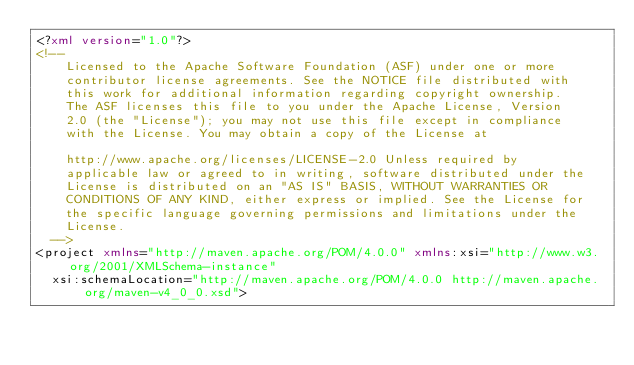<code> <loc_0><loc_0><loc_500><loc_500><_XML_><?xml version="1.0"?>
<!--
		Licensed to the Apache Software Foundation (ASF) under one or more
		contributor license agreements. See the NOTICE file distributed with
		this work for additional information regarding copyright ownership.
		The ASF licenses this file to you under the Apache License, Version
		2.0 (the "License"); you may not use this file except in compliance
		with the License. You may obtain a copy of the License at

		http://www.apache.org/licenses/LICENSE-2.0 Unless required by
		applicable law or agreed to in writing, software distributed under the
		License is distributed on an "AS IS" BASIS, WITHOUT WARRANTIES OR
		CONDITIONS OF ANY KIND, either express or implied. See the License for
		the specific language governing permissions and limitations under the
		License.
	-->
<project xmlns="http://maven.apache.org/POM/4.0.0" xmlns:xsi="http://www.w3.org/2001/XMLSchema-instance"
	xsi:schemaLocation="http://maven.apache.org/POM/4.0.0 http://maven.apache.org/maven-v4_0_0.xsd"></code> 